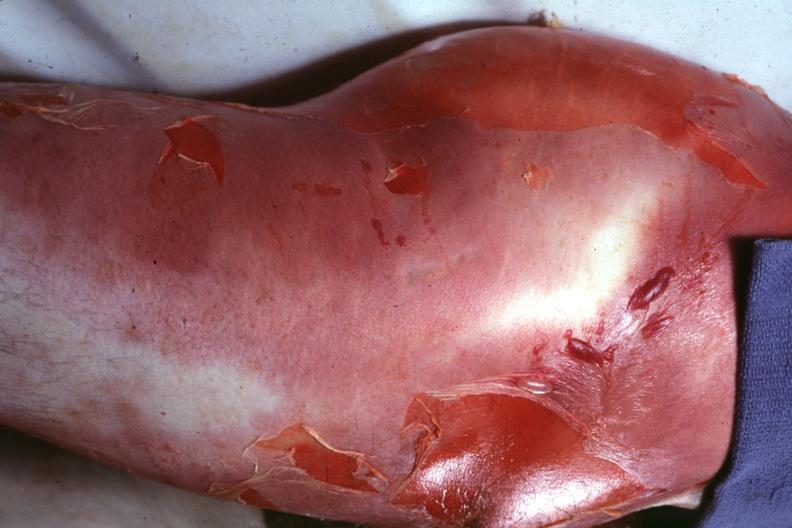does this image show buttock and thigh with severe cellulitis and desquamation caused by a clostridium?
Answer the question using a single word or phrase. Yes 